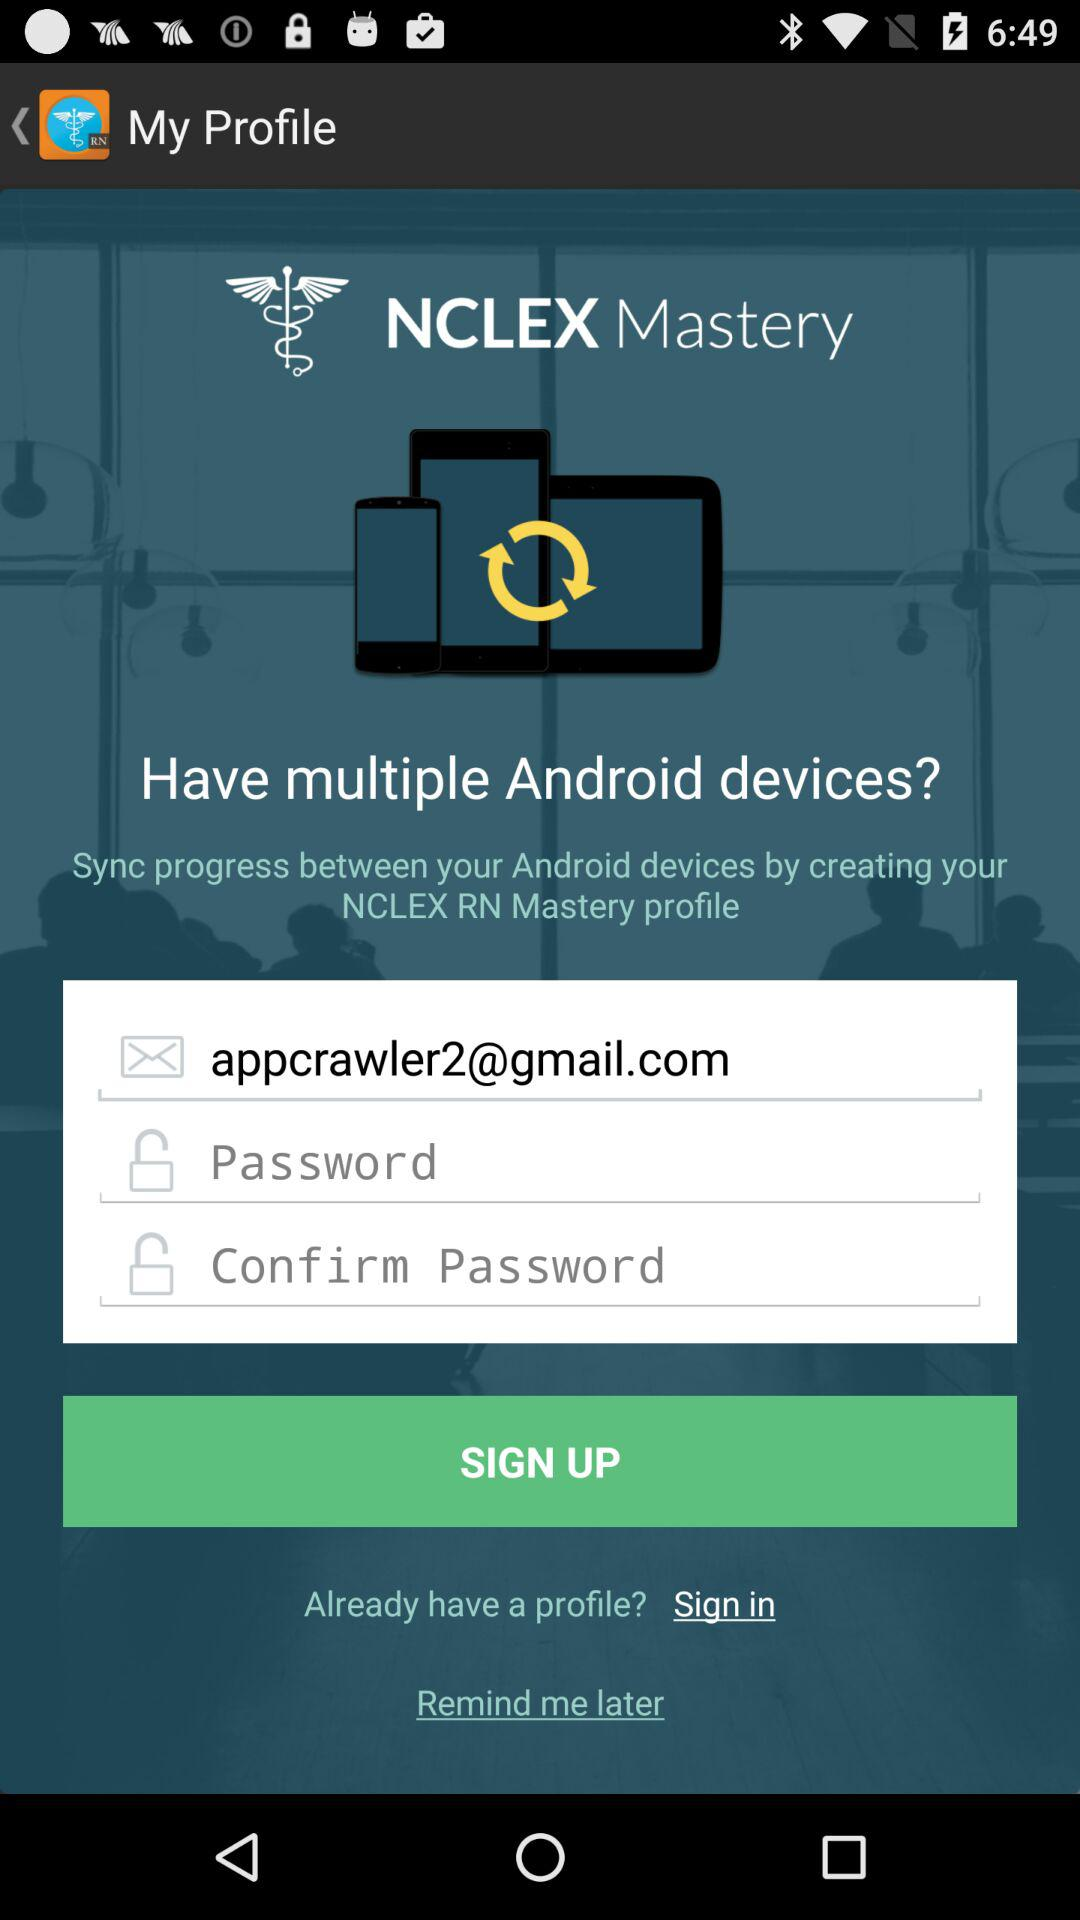What is the application name? The name of the application is "NCLEX Mastery". 